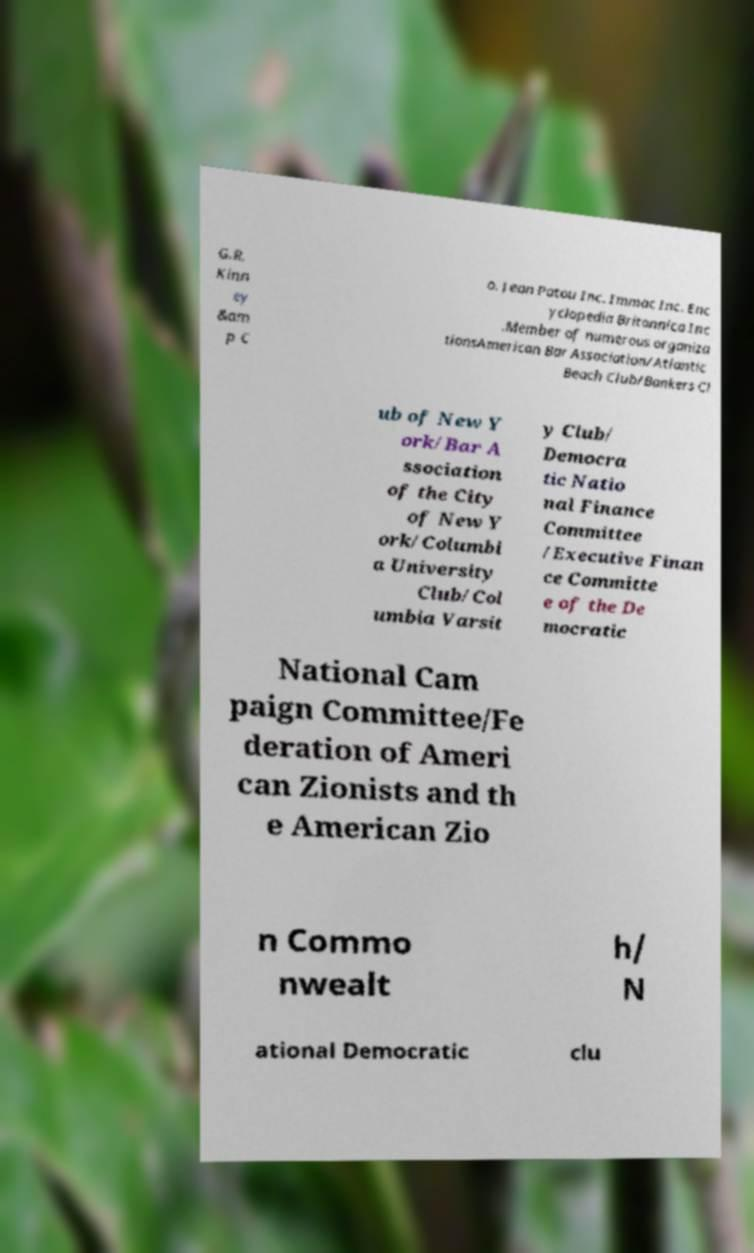I need the written content from this picture converted into text. Can you do that? G.R. Kinn ey &am p C o. Jean Patou Inc. Immac Inc. Enc yclopedia Britannica Inc .Member of numerous organiza tionsAmerican Bar Association/Atlantic Beach Club/Bankers Cl ub of New Y ork/Bar A ssociation of the City of New Y ork/Columbi a University Club/Col umbia Varsit y Club/ Democra tic Natio nal Finance Committee /Executive Finan ce Committe e of the De mocratic National Cam paign Committee/Fe deration of Ameri can Zionists and th e American Zio n Commo nwealt h/ N ational Democratic clu 